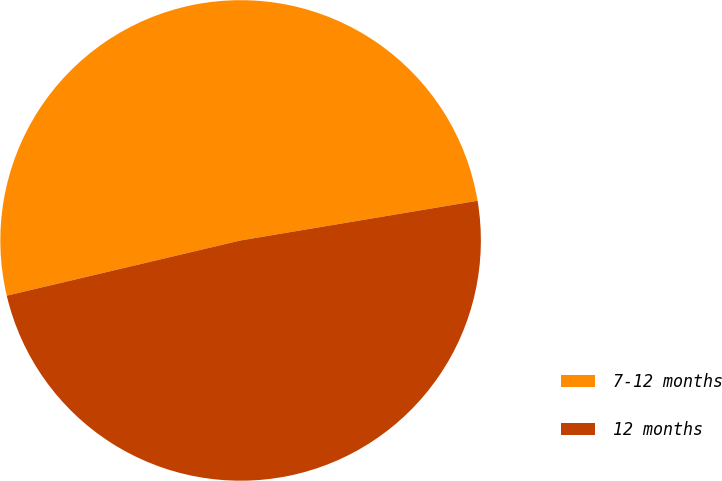Convert chart. <chart><loc_0><loc_0><loc_500><loc_500><pie_chart><fcel>7-12 months<fcel>12 months<nl><fcel>51.05%<fcel>48.95%<nl></chart> 